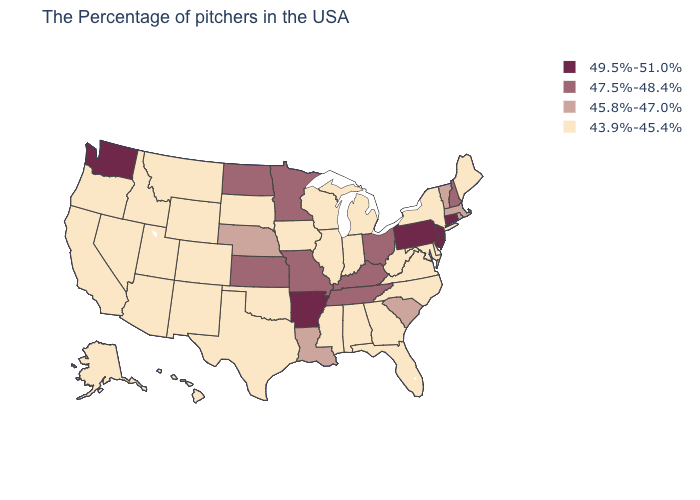Does the first symbol in the legend represent the smallest category?
Give a very brief answer. No. What is the highest value in the USA?
Short answer required. 49.5%-51.0%. How many symbols are there in the legend?
Give a very brief answer. 4. Among the states that border Oregon , which have the lowest value?
Write a very short answer. Idaho, Nevada, California. What is the value of New Hampshire?
Short answer required. 47.5%-48.4%. Does Alabama have the same value as Florida?
Give a very brief answer. Yes. Name the states that have a value in the range 47.5%-48.4%?
Quick response, please. New Hampshire, Ohio, Kentucky, Tennessee, Missouri, Minnesota, Kansas, North Dakota. Does Mississippi have the lowest value in the USA?
Short answer required. Yes. Name the states that have a value in the range 43.9%-45.4%?
Short answer required. Maine, New York, Delaware, Maryland, Virginia, North Carolina, West Virginia, Florida, Georgia, Michigan, Indiana, Alabama, Wisconsin, Illinois, Mississippi, Iowa, Oklahoma, Texas, South Dakota, Wyoming, Colorado, New Mexico, Utah, Montana, Arizona, Idaho, Nevada, California, Oregon, Alaska, Hawaii. What is the value of Illinois?
Answer briefly. 43.9%-45.4%. Does Missouri have a higher value than South Dakota?
Quick response, please. Yes. What is the lowest value in states that border Wisconsin?
Answer briefly. 43.9%-45.4%. Name the states that have a value in the range 49.5%-51.0%?
Quick response, please. Connecticut, New Jersey, Pennsylvania, Arkansas, Washington. Name the states that have a value in the range 45.8%-47.0%?
Give a very brief answer. Massachusetts, Rhode Island, Vermont, South Carolina, Louisiana, Nebraska. Does Ohio have the highest value in the USA?
Write a very short answer. No. 